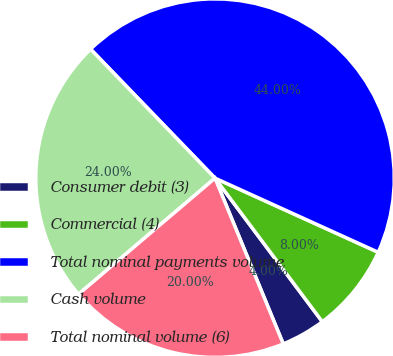<chart> <loc_0><loc_0><loc_500><loc_500><pie_chart><fcel>Consumer debit (3)<fcel>Commercial (4)<fcel>Total nominal payments volume<fcel>Cash volume<fcel>Total nominal volume (6)<nl><fcel>4.0%<fcel>8.0%<fcel>44.0%<fcel>24.0%<fcel>20.0%<nl></chart> 